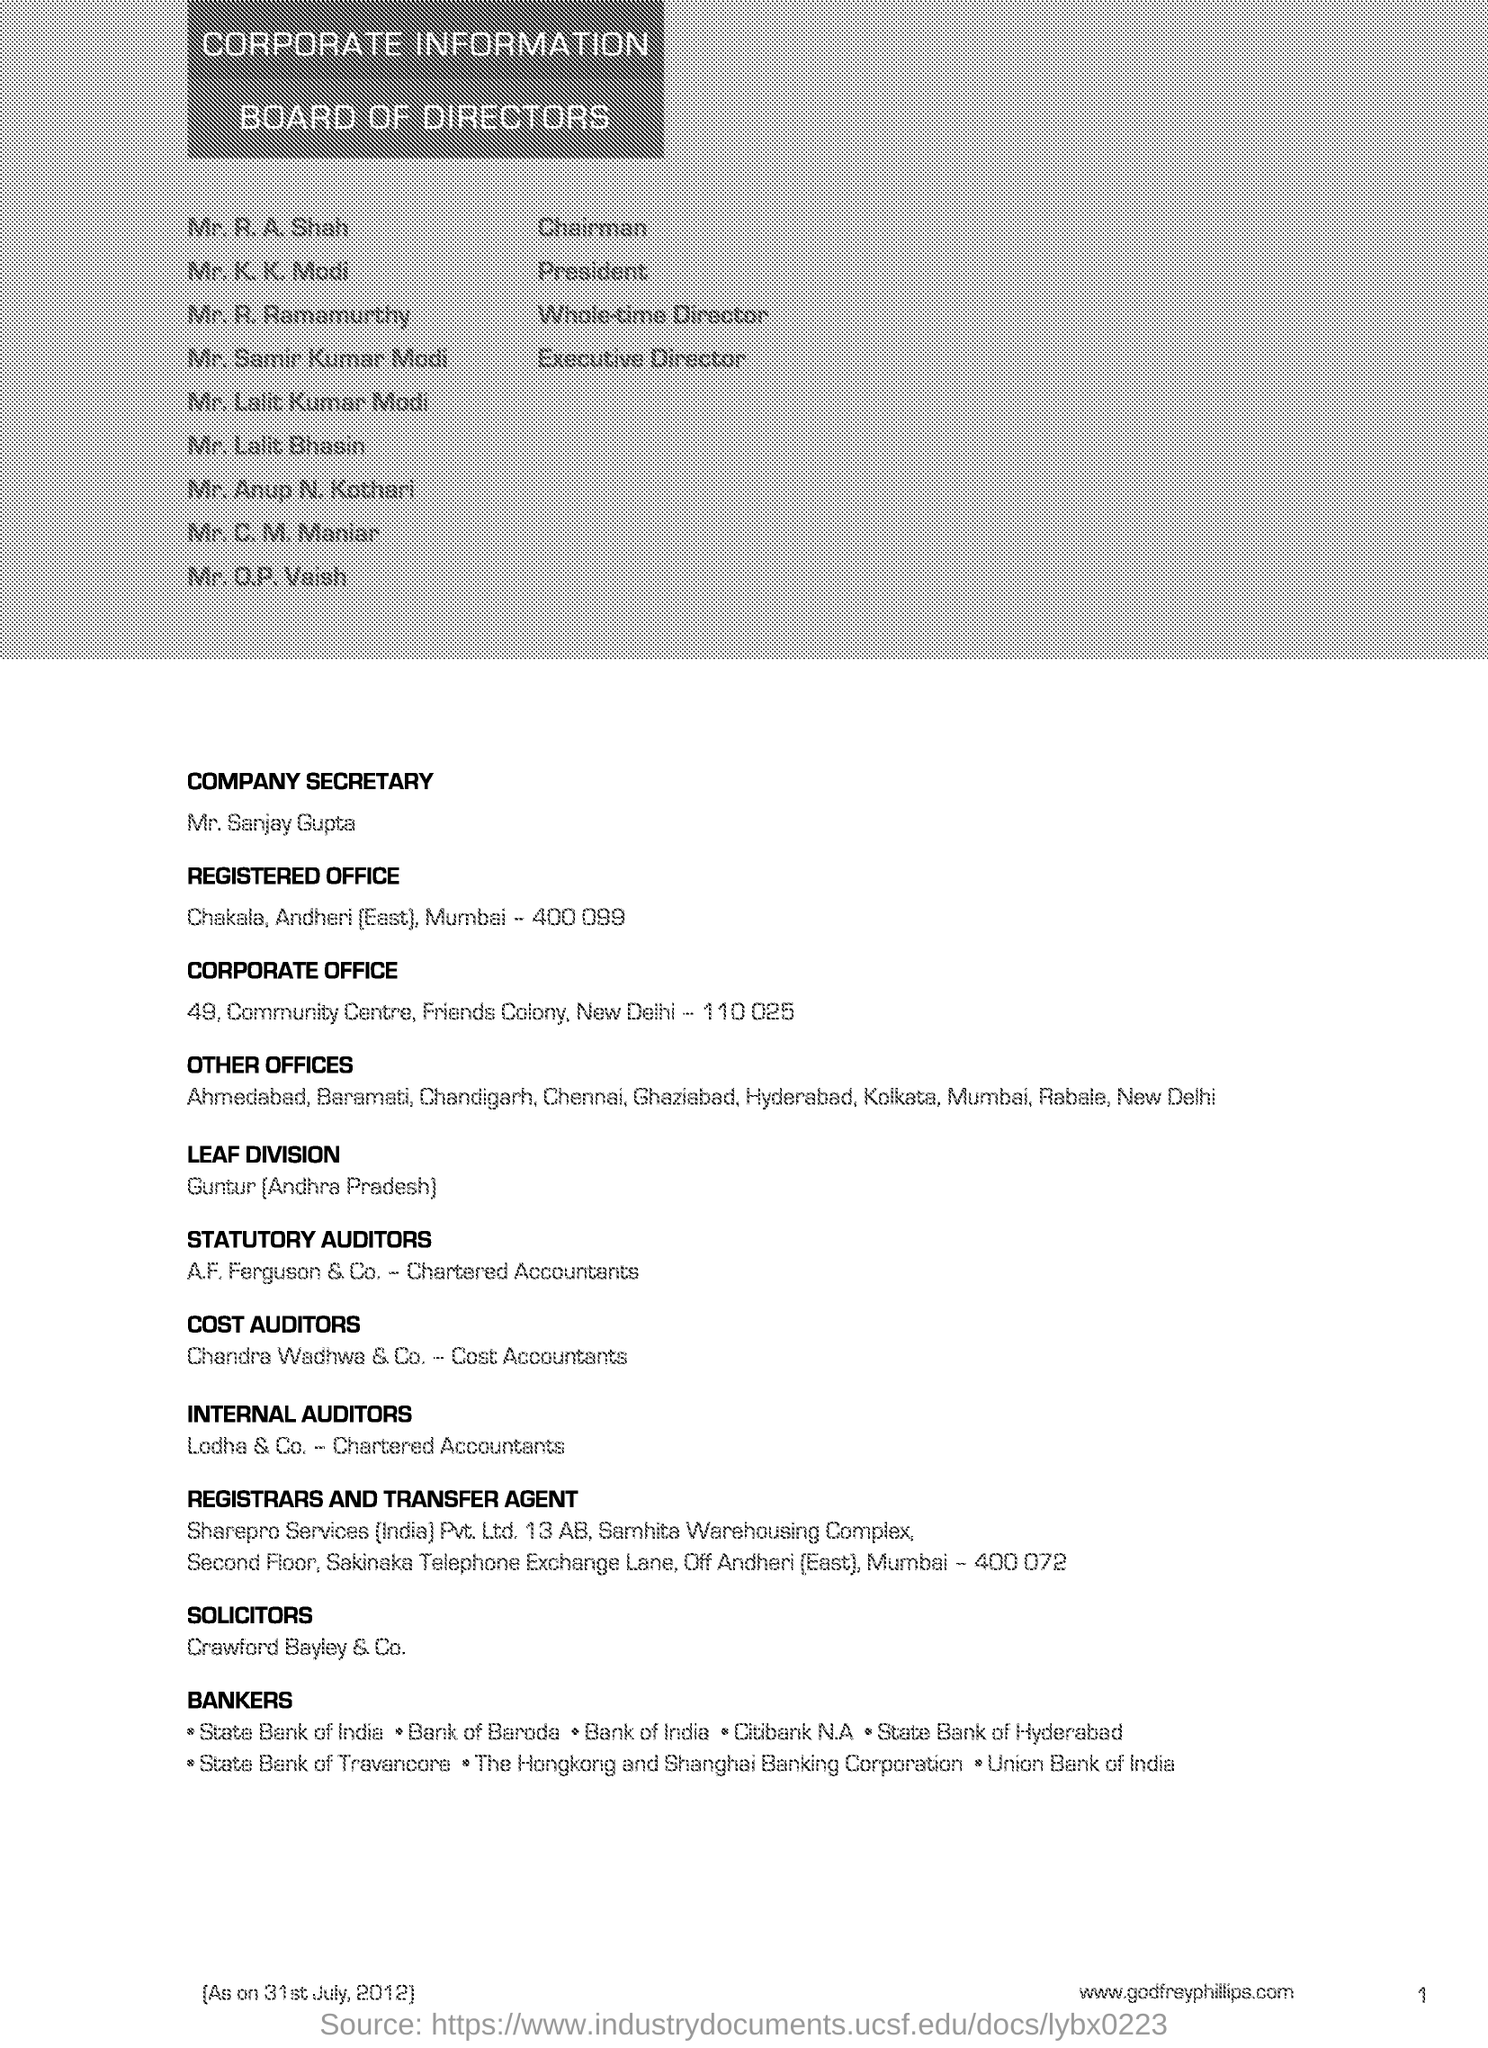Identify some key points in this picture. Leaf division is situated in Guntur, Andhra Pradesh. 